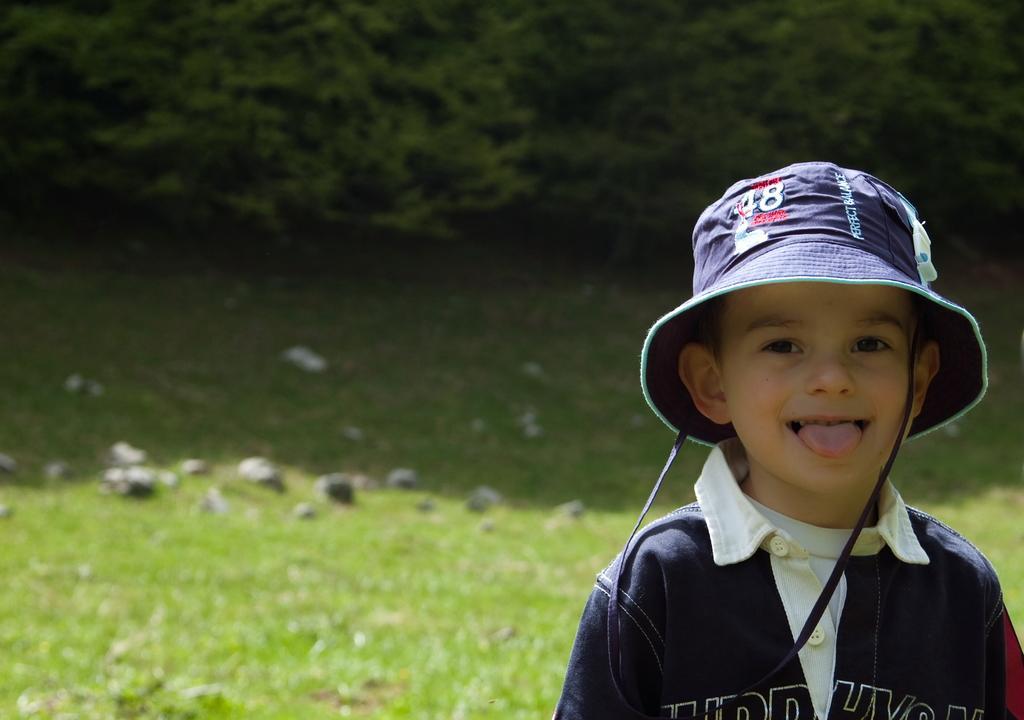How would you summarize this image in a sentence or two? This picture shows a boy standing and he wore a cap on his head and we see grass on the ground and few stones and we see trees and boy wore a blue t-shirt. 